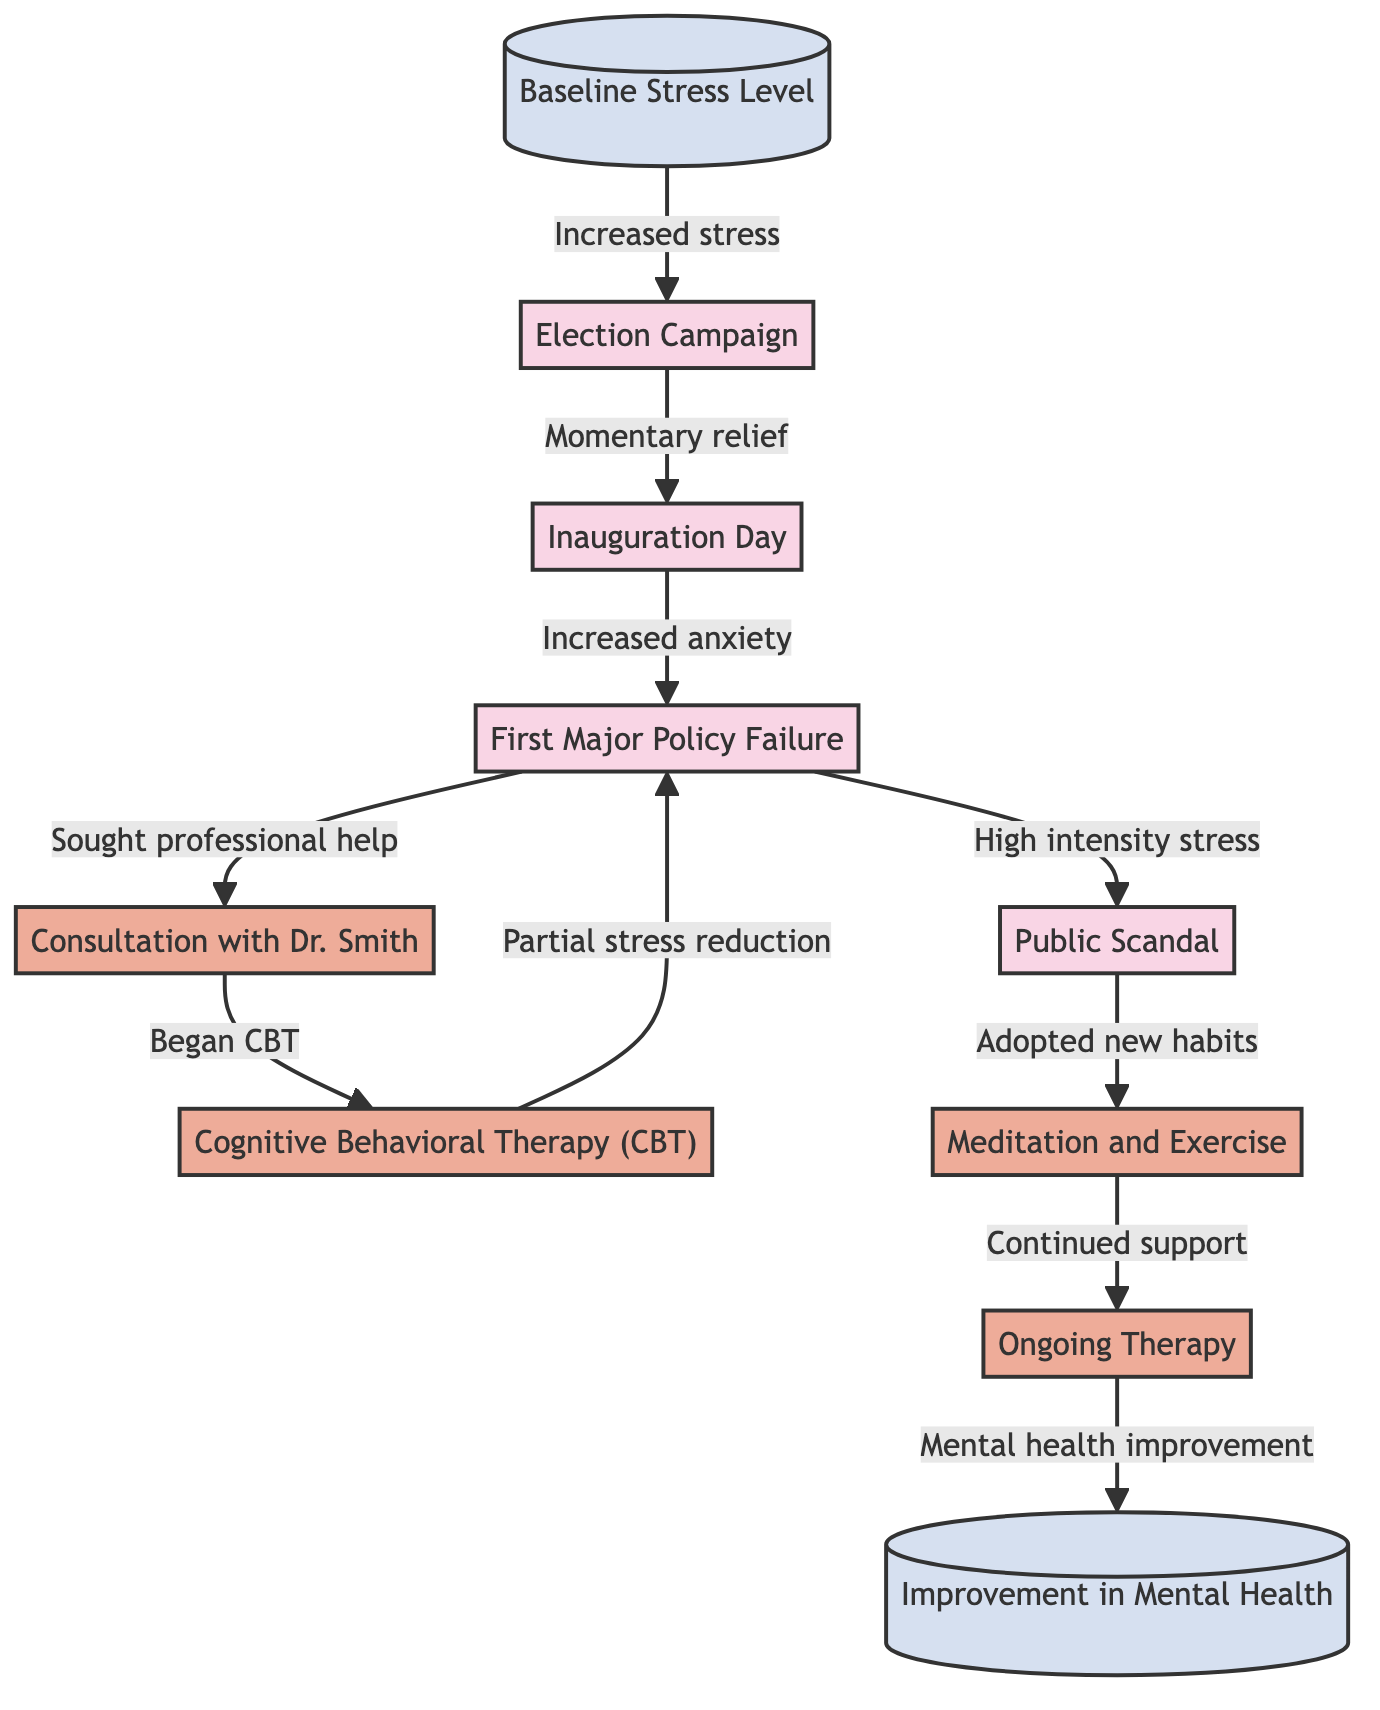What is the first event listed in the diagram? The first event shown in the diagram is "Election Campaign." It can be found right after the initial status of "Baseline Stress Level" and is the second node in the flow.
Answer: Election Campaign How many interventions are included in the diagram? The diagram includes four interventions: "Consultation with Dr. Smith," "Cognitive Behavioral Therapy (CBT)," "Meditation and Exercise," and "Ongoing Therapy." By counting these nodes, we see there are four distinct interventions.
Answer: 4 What is the connection between "First Major Policy Failure" and "Public Scandal"? The diagram illustrates that "First Major Policy Failure" leads to "Sought professional help," which connects to the intervention "Consultation with Dr. Smith." Additionally, "First Major Policy Failure" also connects to "Public Scandal," indicating a direct relationship between them.
Answer: Sought professional help Which intervention comes after "Began CBT"? After "Began CBT," the next intervention listed is "Public Scandal." The flow indicates the sequential progression of events leading to additional stress and the necessity of further interventions.
Answer: Public Scandal What significant event follows "Inauguration Day"? Following "Inauguration Day," the significant event that occurs is "First Major Policy Failure." This is indicated by the direct flow from "Inauguration Day" to "First Major Policy Failure."
Answer: First Major Policy Failure Which status is indicated at the end of the diagram? The final status indicated at the end of the diagram is "Improvement in Mental Health." This is reached after the various events and interventions have taken place, leading to a positive conclusion.
Answer: Improvement in Mental Health What does "Adopted new habits" lead to? "Adopted new habits" leads to "Continued support," which is another intervention that follows it in the flow of the diagram. This highlights the sequential relationship between adopting new habits and receiving ongoing support.
Answer: Continued support What is the relationship between "Consultation with Dr. Smith" and "Cognitive Behavioral Therapy (CBT)"? "Consultation with Dr. Smith" leads to the intervention "Began CBT." This indicates a cause-and-effect relationship where consulting a doctor prompts the start of therapy.
Answer: Began CBT 